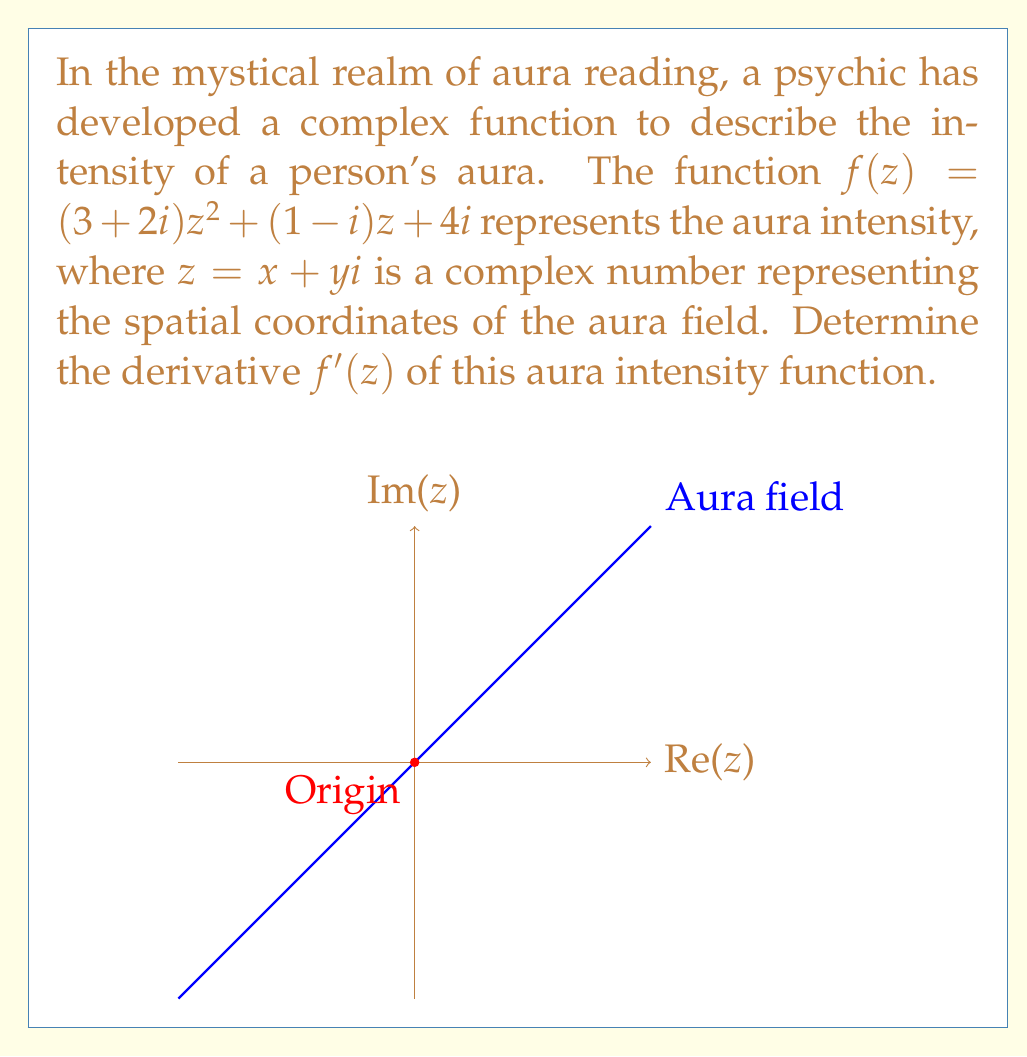Could you help me with this problem? To find the derivative of the complex function $f(z)$, we'll use the rules of complex differentiation:

1) First, recall that for a complex function $f(z) = u(x,y) + iv(x,y)$, the derivative exists if the Cauchy-Riemann equations are satisfied and $u$ and $v$ have continuous partial derivatives.

2) In this case, we don't need to check the Cauchy-Riemann equations because our function is analytic (it's a polynomial in $z$).

3) To differentiate $f(z)$, we can treat $z$ as a variable and use the standard rules of differentiation:

   $f(z) = (3+2i)z^2 + (1-i)z + 4i$

4) Let's differentiate term by term:
   
   a) $\frac{d}{dz}[(3+2i)z^2] = 2(3+2i)z$
   
   b) $\frac{d}{dz}[(1-i)z] = 1-i$
   
   c) $\frac{d}{dz}[4i] = 0$

5) Adding these terms together:

   $f'(z) = 2(3+2i)z + (1-i) + 0$

6) Simplifying:

   $f'(z) = (6+4i)z + 1-i$

This is the derivative of the aura intensity function.
Answer: $f'(z) = (6+4i)z + 1-i$ 